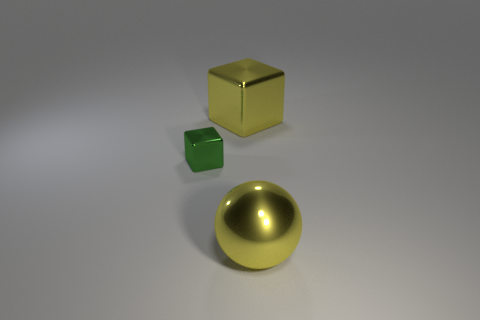Can you tell me what the golden object in the image is meant to represent? The golden object appears to be a sphere, possibly representative of a ball or a spherical decorative element given its shiny, reflective surface and the way it contrasts with the other geometric shapes. Is there any real-world significance to these objects? Without more context, it's difficult to ascribe real-world significance to these objects. They might simply be a collection of shapes used to demonstrate 3D rendering or to create an aesthetically pleasing composition. 